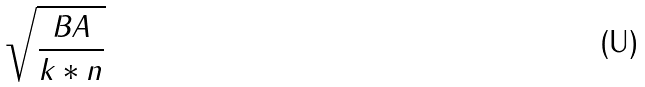<formula> <loc_0><loc_0><loc_500><loc_500>\sqrt { \frac { B A } { k * n } }</formula> 